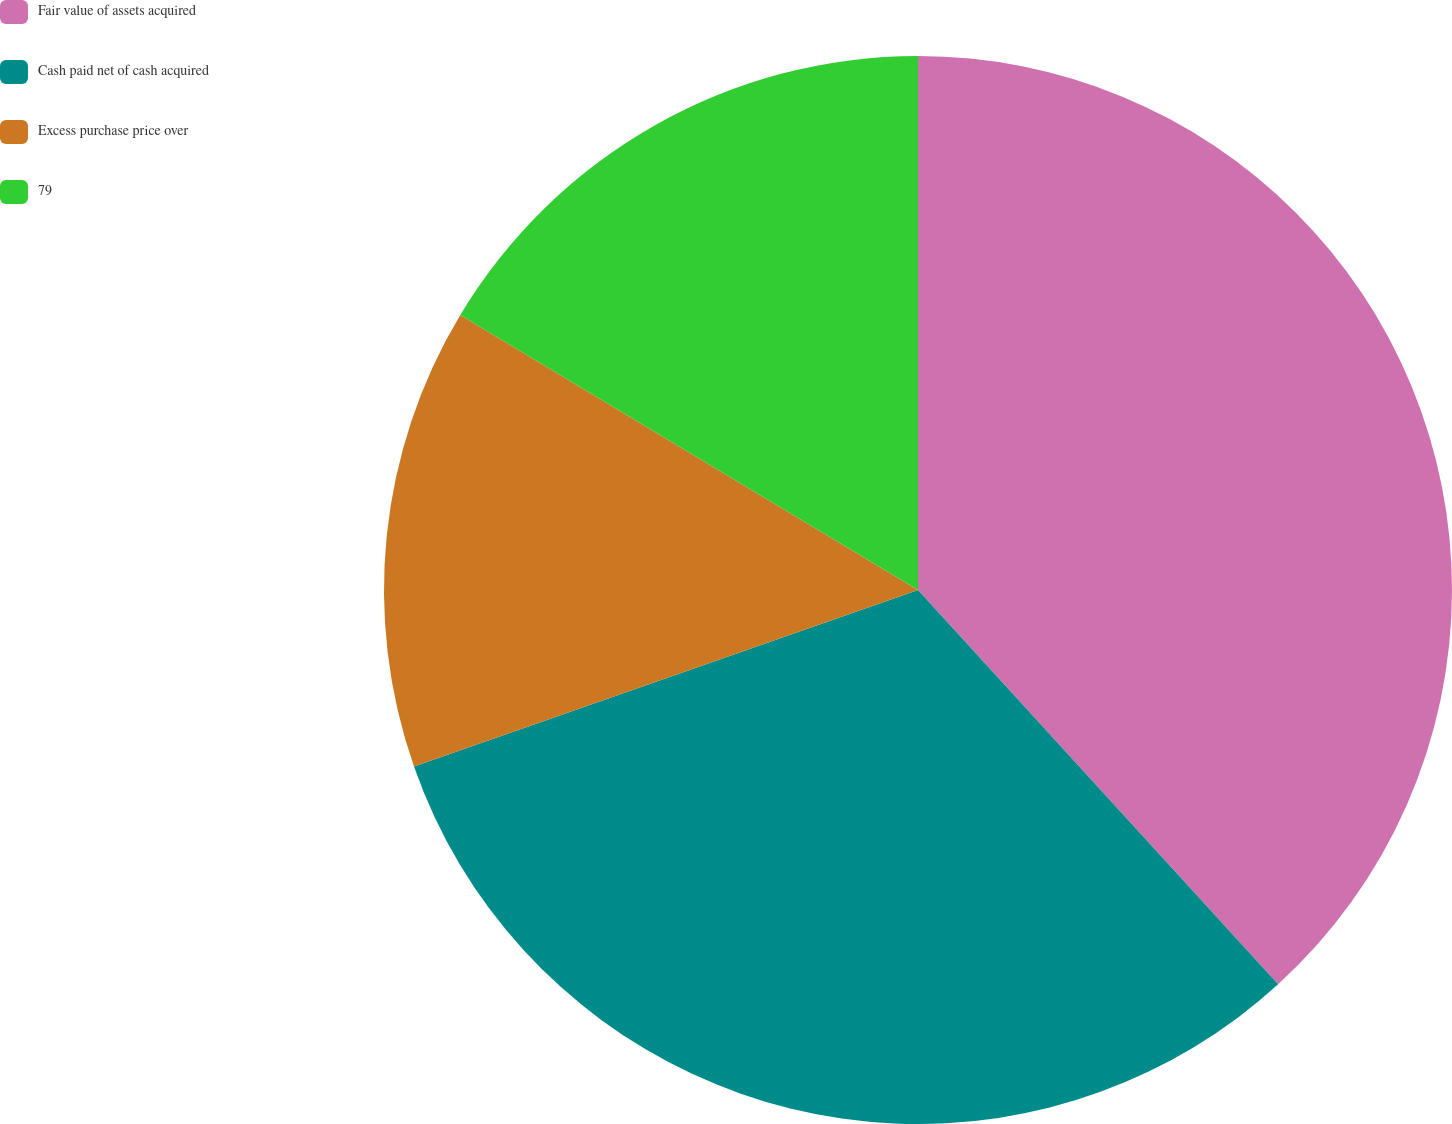Convert chart to OTSL. <chart><loc_0><loc_0><loc_500><loc_500><pie_chart><fcel>Fair value of assets acquired<fcel>Cash paid net of cash acquired<fcel>Excess purchase price over<fcel>79<nl><fcel>38.22%<fcel>31.42%<fcel>13.97%<fcel>16.39%<nl></chart> 